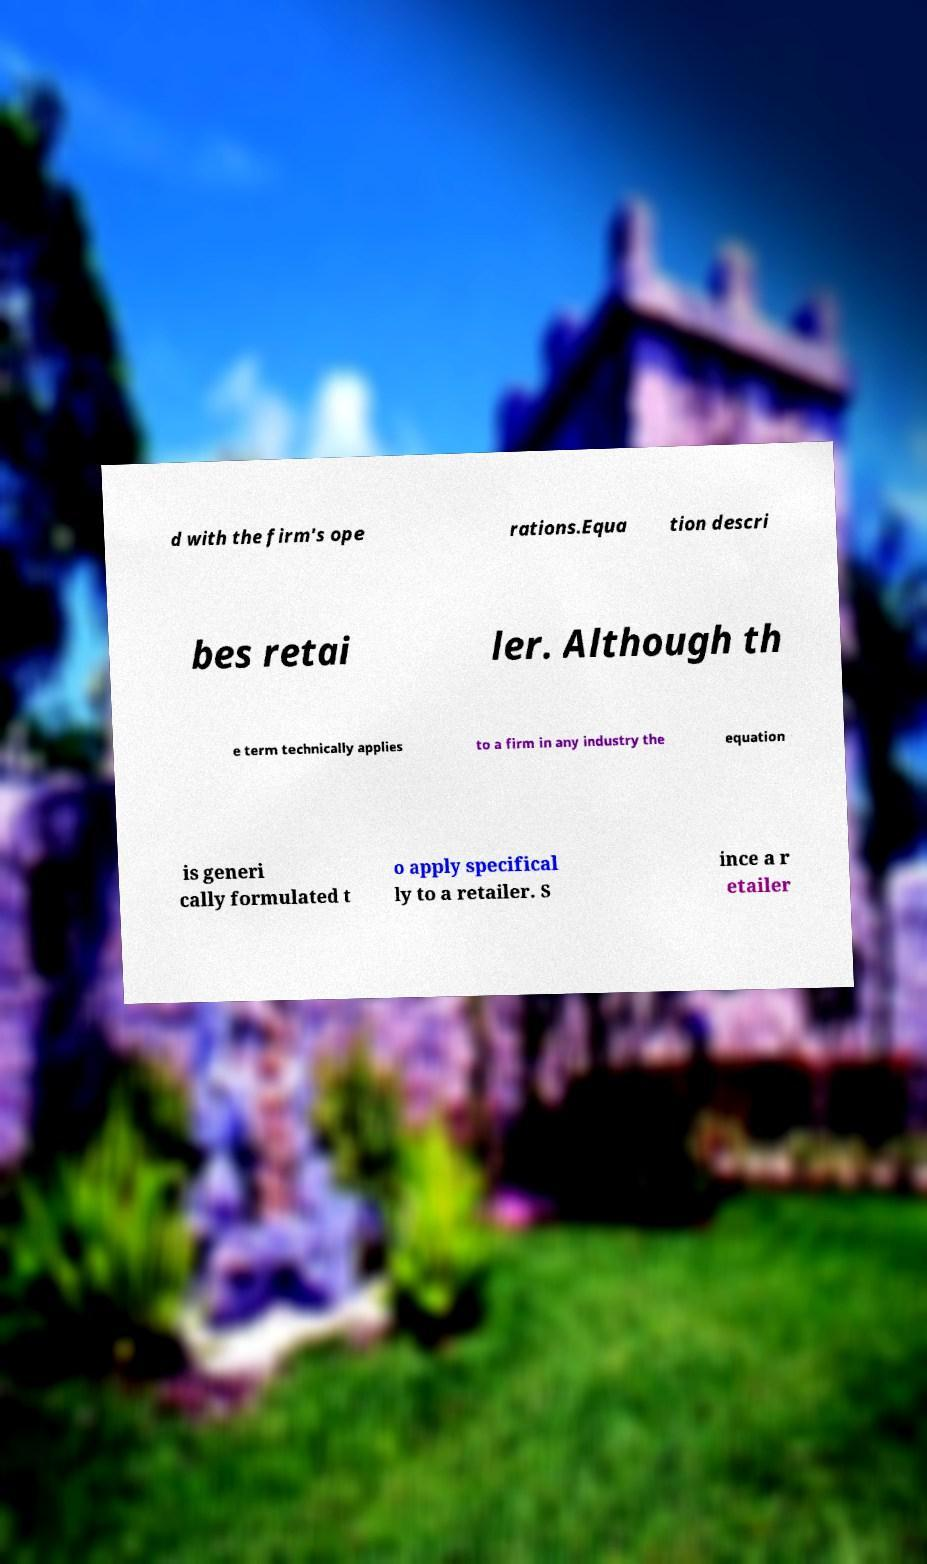Can you read and provide the text displayed in the image?This photo seems to have some interesting text. Can you extract and type it out for me? d with the firm's ope rations.Equa tion descri bes retai ler. Although th e term technically applies to a firm in any industry the equation is generi cally formulated t o apply specifical ly to a retailer. S ince a r etailer 